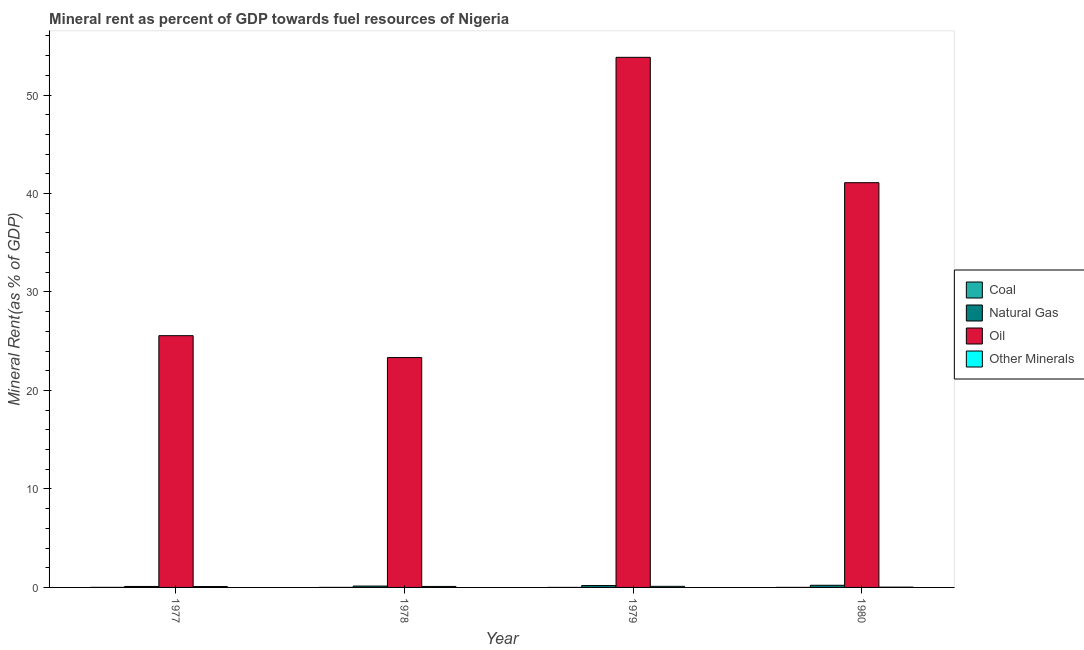How many different coloured bars are there?
Provide a short and direct response. 4. How many groups of bars are there?
Offer a very short reply. 4. Are the number of bars per tick equal to the number of legend labels?
Provide a succinct answer. Yes. How many bars are there on the 3rd tick from the right?
Your answer should be very brief. 4. What is the label of the 4th group of bars from the left?
Give a very brief answer. 1980. In how many cases, is the number of bars for a given year not equal to the number of legend labels?
Make the answer very short. 0. What is the  rent of other minerals in 1979?
Keep it short and to the point. 0.11. Across all years, what is the maximum natural gas rent?
Give a very brief answer. 0.22. Across all years, what is the minimum  rent of other minerals?
Give a very brief answer. 0.03. In which year was the oil rent maximum?
Your answer should be very brief. 1979. In which year was the  rent of other minerals minimum?
Provide a short and direct response. 1980. What is the total natural gas rent in the graph?
Your answer should be compact. 0.64. What is the difference between the coal rent in 1978 and that in 1979?
Your response must be concise. 0. What is the difference between the natural gas rent in 1979 and the oil rent in 1978?
Provide a short and direct response. 0.05. What is the average oil rent per year?
Provide a short and direct response. 35.96. In how many years, is the coal rent greater than 52 %?
Give a very brief answer. 0. What is the ratio of the  rent of other minerals in 1977 to that in 1978?
Give a very brief answer. 0.9. Is the difference between the oil rent in 1977 and 1979 greater than the difference between the  rent of other minerals in 1977 and 1979?
Offer a terse response. No. What is the difference between the highest and the second highest coal rent?
Provide a succinct answer. 0. What is the difference between the highest and the lowest natural gas rent?
Offer a terse response. 0.12. In how many years, is the natural gas rent greater than the average natural gas rent taken over all years?
Offer a terse response. 2. Is it the case that in every year, the sum of the oil rent and coal rent is greater than the sum of natural gas rent and  rent of other minerals?
Give a very brief answer. No. What does the 4th bar from the left in 1977 represents?
Ensure brevity in your answer.  Other Minerals. What does the 4th bar from the right in 1979 represents?
Keep it short and to the point. Coal. Is it the case that in every year, the sum of the coal rent and natural gas rent is greater than the oil rent?
Provide a short and direct response. No. How many bars are there?
Provide a short and direct response. 16. What is the difference between two consecutive major ticks on the Y-axis?
Provide a succinct answer. 10. How are the legend labels stacked?
Your answer should be very brief. Vertical. What is the title of the graph?
Offer a very short reply. Mineral rent as percent of GDP towards fuel resources of Nigeria. What is the label or title of the X-axis?
Make the answer very short. Year. What is the label or title of the Y-axis?
Your response must be concise. Mineral Rent(as % of GDP). What is the Mineral Rent(as % of GDP) in Coal in 1977?
Your response must be concise. 0. What is the Mineral Rent(as % of GDP) in Natural Gas in 1977?
Your answer should be very brief. 0.1. What is the Mineral Rent(as % of GDP) in Oil in 1977?
Your response must be concise. 25.56. What is the Mineral Rent(as % of GDP) of Other Minerals in 1977?
Provide a succinct answer. 0.09. What is the Mineral Rent(as % of GDP) in Coal in 1978?
Keep it short and to the point. 0. What is the Mineral Rent(as % of GDP) in Natural Gas in 1978?
Provide a succinct answer. 0.14. What is the Mineral Rent(as % of GDP) in Oil in 1978?
Provide a short and direct response. 23.34. What is the Mineral Rent(as % of GDP) of Other Minerals in 1978?
Your response must be concise. 0.1. What is the Mineral Rent(as % of GDP) in Coal in 1979?
Your answer should be very brief. 0. What is the Mineral Rent(as % of GDP) in Natural Gas in 1979?
Ensure brevity in your answer.  0.19. What is the Mineral Rent(as % of GDP) in Oil in 1979?
Offer a terse response. 53.83. What is the Mineral Rent(as % of GDP) of Other Minerals in 1979?
Your answer should be compact. 0.11. What is the Mineral Rent(as % of GDP) in Coal in 1980?
Offer a very short reply. 0. What is the Mineral Rent(as % of GDP) of Natural Gas in 1980?
Provide a succinct answer. 0.22. What is the Mineral Rent(as % of GDP) in Oil in 1980?
Ensure brevity in your answer.  41.1. What is the Mineral Rent(as % of GDP) of Other Minerals in 1980?
Make the answer very short. 0.03. Across all years, what is the maximum Mineral Rent(as % of GDP) of Coal?
Your answer should be very brief. 0. Across all years, what is the maximum Mineral Rent(as % of GDP) of Natural Gas?
Your answer should be compact. 0.22. Across all years, what is the maximum Mineral Rent(as % of GDP) in Oil?
Keep it short and to the point. 53.83. Across all years, what is the maximum Mineral Rent(as % of GDP) in Other Minerals?
Provide a succinct answer. 0.11. Across all years, what is the minimum Mineral Rent(as % of GDP) of Coal?
Your answer should be very brief. 0. Across all years, what is the minimum Mineral Rent(as % of GDP) in Natural Gas?
Provide a succinct answer. 0.1. Across all years, what is the minimum Mineral Rent(as % of GDP) in Oil?
Make the answer very short. 23.34. Across all years, what is the minimum Mineral Rent(as % of GDP) of Other Minerals?
Your answer should be compact. 0.03. What is the total Mineral Rent(as % of GDP) in Coal in the graph?
Provide a succinct answer. 0.01. What is the total Mineral Rent(as % of GDP) in Natural Gas in the graph?
Give a very brief answer. 0.64. What is the total Mineral Rent(as % of GDP) in Oil in the graph?
Keep it short and to the point. 143.83. What is the total Mineral Rent(as % of GDP) in Other Minerals in the graph?
Ensure brevity in your answer.  0.33. What is the difference between the Mineral Rent(as % of GDP) in Coal in 1977 and that in 1978?
Your answer should be compact. 0. What is the difference between the Mineral Rent(as % of GDP) in Natural Gas in 1977 and that in 1978?
Give a very brief answer. -0.04. What is the difference between the Mineral Rent(as % of GDP) in Oil in 1977 and that in 1978?
Your response must be concise. 2.22. What is the difference between the Mineral Rent(as % of GDP) of Other Minerals in 1977 and that in 1978?
Keep it short and to the point. -0.01. What is the difference between the Mineral Rent(as % of GDP) in Coal in 1977 and that in 1979?
Your answer should be compact. 0. What is the difference between the Mineral Rent(as % of GDP) of Natural Gas in 1977 and that in 1979?
Offer a terse response. -0.09. What is the difference between the Mineral Rent(as % of GDP) in Oil in 1977 and that in 1979?
Keep it short and to the point. -28.26. What is the difference between the Mineral Rent(as % of GDP) of Other Minerals in 1977 and that in 1979?
Ensure brevity in your answer.  -0.02. What is the difference between the Mineral Rent(as % of GDP) of Coal in 1977 and that in 1980?
Ensure brevity in your answer.  0. What is the difference between the Mineral Rent(as % of GDP) of Natural Gas in 1977 and that in 1980?
Your answer should be compact. -0.12. What is the difference between the Mineral Rent(as % of GDP) in Oil in 1977 and that in 1980?
Your response must be concise. -15.53. What is the difference between the Mineral Rent(as % of GDP) in Other Minerals in 1977 and that in 1980?
Ensure brevity in your answer.  0.06. What is the difference between the Mineral Rent(as % of GDP) in Coal in 1978 and that in 1979?
Offer a very short reply. 0. What is the difference between the Mineral Rent(as % of GDP) in Natural Gas in 1978 and that in 1979?
Make the answer very short. -0.05. What is the difference between the Mineral Rent(as % of GDP) in Oil in 1978 and that in 1979?
Offer a very short reply. -30.49. What is the difference between the Mineral Rent(as % of GDP) in Other Minerals in 1978 and that in 1979?
Offer a terse response. -0.01. What is the difference between the Mineral Rent(as % of GDP) of Coal in 1978 and that in 1980?
Offer a terse response. -0. What is the difference between the Mineral Rent(as % of GDP) in Natural Gas in 1978 and that in 1980?
Provide a short and direct response. -0.08. What is the difference between the Mineral Rent(as % of GDP) of Oil in 1978 and that in 1980?
Ensure brevity in your answer.  -17.76. What is the difference between the Mineral Rent(as % of GDP) in Other Minerals in 1978 and that in 1980?
Give a very brief answer. 0.07. What is the difference between the Mineral Rent(as % of GDP) in Coal in 1979 and that in 1980?
Keep it short and to the point. -0. What is the difference between the Mineral Rent(as % of GDP) of Natural Gas in 1979 and that in 1980?
Offer a very short reply. -0.03. What is the difference between the Mineral Rent(as % of GDP) in Oil in 1979 and that in 1980?
Give a very brief answer. 12.73. What is the difference between the Mineral Rent(as % of GDP) in Other Minerals in 1979 and that in 1980?
Give a very brief answer. 0.08. What is the difference between the Mineral Rent(as % of GDP) of Coal in 1977 and the Mineral Rent(as % of GDP) of Natural Gas in 1978?
Offer a very short reply. -0.14. What is the difference between the Mineral Rent(as % of GDP) in Coal in 1977 and the Mineral Rent(as % of GDP) in Oil in 1978?
Give a very brief answer. -23.34. What is the difference between the Mineral Rent(as % of GDP) of Coal in 1977 and the Mineral Rent(as % of GDP) of Other Minerals in 1978?
Keep it short and to the point. -0.1. What is the difference between the Mineral Rent(as % of GDP) of Natural Gas in 1977 and the Mineral Rent(as % of GDP) of Oil in 1978?
Offer a very short reply. -23.24. What is the difference between the Mineral Rent(as % of GDP) of Natural Gas in 1977 and the Mineral Rent(as % of GDP) of Other Minerals in 1978?
Provide a short and direct response. -0. What is the difference between the Mineral Rent(as % of GDP) of Oil in 1977 and the Mineral Rent(as % of GDP) of Other Minerals in 1978?
Ensure brevity in your answer.  25.46. What is the difference between the Mineral Rent(as % of GDP) of Coal in 1977 and the Mineral Rent(as % of GDP) of Natural Gas in 1979?
Provide a short and direct response. -0.19. What is the difference between the Mineral Rent(as % of GDP) of Coal in 1977 and the Mineral Rent(as % of GDP) of Oil in 1979?
Ensure brevity in your answer.  -53.82. What is the difference between the Mineral Rent(as % of GDP) in Coal in 1977 and the Mineral Rent(as % of GDP) in Other Minerals in 1979?
Ensure brevity in your answer.  -0.11. What is the difference between the Mineral Rent(as % of GDP) in Natural Gas in 1977 and the Mineral Rent(as % of GDP) in Oil in 1979?
Offer a terse response. -53.73. What is the difference between the Mineral Rent(as % of GDP) of Natural Gas in 1977 and the Mineral Rent(as % of GDP) of Other Minerals in 1979?
Your response must be concise. -0.01. What is the difference between the Mineral Rent(as % of GDP) in Oil in 1977 and the Mineral Rent(as % of GDP) in Other Minerals in 1979?
Make the answer very short. 25.45. What is the difference between the Mineral Rent(as % of GDP) of Coal in 1977 and the Mineral Rent(as % of GDP) of Natural Gas in 1980?
Ensure brevity in your answer.  -0.21. What is the difference between the Mineral Rent(as % of GDP) of Coal in 1977 and the Mineral Rent(as % of GDP) of Oil in 1980?
Give a very brief answer. -41.09. What is the difference between the Mineral Rent(as % of GDP) of Coal in 1977 and the Mineral Rent(as % of GDP) of Other Minerals in 1980?
Your answer should be compact. -0.02. What is the difference between the Mineral Rent(as % of GDP) in Natural Gas in 1977 and the Mineral Rent(as % of GDP) in Oil in 1980?
Provide a short and direct response. -41. What is the difference between the Mineral Rent(as % of GDP) in Natural Gas in 1977 and the Mineral Rent(as % of GDP) in Other Minerals in 1980?
Ensure brevity in your answer.  0.07. What is the difference between the Mineral Rent(as % of GDP) of Oil in 1977 and the Mineral Rent(as % of GDP) of Other Minerals in 1980?
Ensure brevity in your answer.  25.54. What is the difference between the Mineral Rent(as % of GDP) in Coal in 1978 and the Mineral Rent(as % of GDP) in Natural Gas in 1979?
Your answer should be compact. -0.19. What is the difference between the Mineral Rent(as % of GDP) in Coal in 1978 and the Mineral Rent(as % of GDP) in Oil in 1979?
Your response must be concise. -53.82. What is the difference between the Mineral Rent(as % of GDP) of Coal in 1978 and the Mineral Rent(as % of GDP) of Other Minerals in 1979?
Offer a very short reply. -0.11. What is the difference between the Mineral Rent(as % of GDP) of Natural Gas in 1978 and the Mineral Rent(as % of GDP) of Oil in 1979?
Give a very brief answer. -53.69. What is the difference between the Mineral Rent(as % of GDP) in Natural Gas in 1978 and the Mineral Rent(as % of GDP) in Other Minerals in 1979?
Make the answer very short. 0.03. What is the difference between the Mineral Rent(as % of GDP) in Oil in 1978 and the Mineral Rent(as % of GDP) in Other Minerals in 1979?
Ensure brevity in your answer.  23.23. What is the difference between the Mineral Rent(as % of GDP) of Coal in 1978 and the Mineral Rent(as % of GDP) of Natural Gas in 1980?
Make the answer very short. -0.22. What is the difference between the Mineral Rent(as % of GDP) in Coal in 1978 and the Mineral Rent(as % of GDP) in Oil in 1980?
Give a very brief answer. -41.09. What is the difference between the Mineral Rent(as % of GDP) in Coal in 1978 and the Mineral Rent(as % of GDP) in Other Minerals in 1980?
Offer a terse response. -0.03. What is the difference between the Mineral Rent(as % of GDP) of Natural Gas in 1978 and the Mineral Rent(as % of GDP) of Oil in 1980?
Keep it short and to the point. -40.96. What is the difference between the Mineral Rent(as % of GDP) of Natural Gas in 1978 and the Mineral Rent(as % of GDP) of Other Minerals in 1980?
Offer a very short reply. 0.11. What is the difference between the Mineral Rent(as % of GDP) of Oil in 1978 and the Mineral Rent(as % of GDP) of Other Minerals in 1980?
Provide a short and direct response. 23.31. What is the difference between the Mineral Rent(as % of GDP) in Coal in 1979 and the Mineral Rent(as % of GDP) in Natural Gas in 1980?
Make the answer very short. -0.22. What is the difference between the Mineral Rent(as % of GDP) of Coal in 1979 and the Mineral Rent(as % of GDP) of Oil in 1980?
Your answer should be compact. -41.1. What is the difference between the Mineral Rent(as % of GDP) in Coal in 1979 and the Mineral Rent(as % of GDP) in Other Minerals in 1980?
Give a very brief answer. -0.03. What is the difference between the Mineral Rent(as % of GDP) of Natural Gas in 1979 and the Mineral Rent(as % of GDP) of Oil in 1980?
Offer a terse response. -40.91. What is the difference between the Mineral Rent(as % of GDP) of Natural Gas in 1979 and the Mineral Rent(as % of GDP) of Other Minerals in 1980?
Your response must be concise. 0.16. What is the difference between the Mineral Rent(as % of GDP) in Oil in 1979 and the Mineral Rent(as % of GDP) in Other Minerals in 1980?
Provide a succinct answer. 53.8. What is the average Mineral Rent(as % of GDP) in Coal per year?
Offer a very short reply. 0. What is the average Mineral Rent(as % of GDP) in Natural Gas per year?
Offer a very short reply. 0.16. What is the average Mineral Rent(as % of GDP) in Oil per year?
Your answer should be compact. 35.96. What is the average Mineral Rent(as % of GDP) in Other Minerals per year?
Offer a terse response. 0.08. In the year 1977, what is the difference between the Mineral Rent(as % of GDP) in Coal and Mineral Rent(as % of GDP) in Natural Gas?
Make the answer very short. -0.09. In the year 1977, what is the difference between the Mineral Rent(as % of GDP) in Coal and Mineral Rent(as % of GDP) in Oil?
Your response must be concise. -25.56. In the year 1977, what is the difference between the Mineral Rent(as % of GDP) of Coal and Mineral Rent(as % of GDP) of Other Minerals?
Offer a very short reply. -0.09. In the year 1977, what is the difference between the Mineral Rent(as % of GDP) of Natural Gas and Mineral Rent(as % of GDP) of Oil?
Your answer should be compact. -25.47. In the year 1977, what is the difference between the Mineral Rent(as % of GDP) of Natural Gas and Mineral Rent(as % of GDP) of Other Minerals?
Offer a very short reply. 0.01. In the year 1977, what is the difference between the Mineral Rent(as % of GDP) of Oil and Mineral Rent(as % of GDP) of Other Minerals?
Your answer should be compact. 25.47. In the year 1978, what is the difference between the Mineral Rent(as % of GDP) in Coal and Mineral Rent(as % of GDP) in Natural Gas?
Provide a short and direct response. -0.14. In the year 1978, what is the difference between the Mineral Rent(as % of GDP) in Coal and Mineral Rent(as % of GDP) in Oil?
Give a very brief answer. -23.34. In the year 1978, what is the difference between the Mineral Rent(as % of GDP) of Coal and Mineral Rent(as % of GDP) of Other Minerals?
Make the answer very short. -0.1. In the year 1978, what is the difference between the Mineral Rent(as % of GDP) in Natural Gas and Mineral Rent(as % of GDP) in Oil?
Offer a very short reply. -23.2. In the year 1978, what is the difference between the Mineral Rent(as % of GDP) in Natural Gas and Mineral Rent(as % of GDP) in Other Minerals?
Your answer should be compact. 0.04. In the year 1978, what is the difference between the Mineral Rent(as % of GDP) of Oil and Mineral Rent(as % of GDP) of Other Minerals?
Your response must be concise. 23.24. In the year 1979, what is the difference between the Mineral Rent(as % of GDP) in Coal and Mineral Rent(as % of GDP) in Natural Gas?
Provide a succinct answer. -0.19. In the year 1979, what is the difference between the Mineral Rent(as % of GDP) of Coal and Mineral Rent(as % of GDP) of Oil?
Your answer should be very brief. -53.83. In the year 1979, what is the difference between the Mineral Rent(as % of GDP) of Coal and Mineral Rent(as % of GDP) of Other Minerals?
Your answer should be compact. -0.11. In the year 1979, what is the difference between the Mineral Rent(as % of GDP) in Natural Gas and Mineral Rent(as % of GDP) in Oil?
Provide a short and direct response. -53.64. In the year 1979, what is the difference between the Mineral Rent(as % of GDP) in Natural Gas and Mineral Rent(as % of GDP) in Other Minerals?
Provide a succinct answer. 0.08. In the year 1979, what is the difference between the Mineral Rent(as % of GDP) in Oil and Mineral Rent(as % of GDP) in Other Minerals?
Keep it short and to the point. 53.72. In the year 1980, what is the difference between the Mineral Rent(as % of GDP) of Coal and Mineral Rent(as % of GDP) of Natural Gas?
Offer a terse response. -0.22. In the year 1980, what is the difference between the Mineral Rent(as % of GDP) in Coal and Mineral Rent(as % of GDP) in Oil?
Offer a terse response. -41.09. In the year 1980, what is the difference between the Mineral Rent(as % of GDP) in Coal and Mineral Rent(as % of GDP) in Other Minerals?
Make the answer very short. -0.03. In the year 1980, what is the difference between the Mineral Rent(as % of GDP) in Natural Gas and Mineral Rent(as % of GDP) in Oil?
Ensure brevity in your answer.  -40.88. In the year 1980, what is the difference between the Mineral Rent(as % of GDP) of Natural Gas and Mineral Rent(as % of GDP) of Other Minerals?
Offer a terse response. 0.19. In the year 1980, what is the difference between the Mineral Rent(as % of GDP) in Oil and Mineral Rent(as % of GDP) in Other Minerals?
Offer a very short reply. 41.07. What is the ratio of the Mineral Rent(as % of GDP) of Coal in 1977 to that in 1978?
Your response must be concise. 1.53. What is the ratio of the Mineral Rent(as % of GDP) in Natural Gas in 1977 to that in 1978?
Your answer should be compact. 0.7. What is the ratio of the Mineral Rent(as % of GDP) of Oil in 1977 to that in 1978?
Keep it short and to the point. 1.1. What is the ratio of the Mineral Rent(as % of GDP) in Other Minerals in 1977 to that in 1978?
Offer a terse response. 0.9. What is the ratio of the Mineral Rent(as % of GDP) of Coal in 1977 to that in 1979?
Your answer should be very brief. 3.22. What is the ratio of the Mineral Rent(as % of GDP) of Natural Gas in 1977 to that in 1979?
Keep it short and to the point. 0.51. What is the ratio of the Mineral Rent(as % of GDP) in Oil in 1977 to that in 1979?
Your answer should be compact. 0.47. What is the ratio of the Mineral Rent(as % of GDP) in Other Minerals in 1977 to that in 1979?
Your answer should be very brief. 0.81. What is the ratio of the Mineral Rent(as % of GDP) of Coal in 1977 to that in 1980?
Give a very brief answer. 1.52. What is the ratio of the Mineral Rent(as % of GDP) of Natural Gas in 1977 to that in 1980?
Your answer should be compact. 0.45. What is the ratio of the Mineral Rent(as % of GDP) of Oil in 1977 to that in 1980?
Offer a terse response. 0.62. What is the ratio of the Mineral Rent(as % of GDP) of Other Minerals in 1977 to that in 1980?
Ensure brevity in your answer.  3.27. What is the ratio of the Mineral Rent(as % of GDP) of Coal in 1978 to that in 1979?
Give a very brief answer. 2.1. What is the ratio of the Mineral Rent(as % of GDP) of Natural Gas in 1978 to that in 1979?
Ensure brevity in your answer.  0.74. What is the ratio of the Mineral Rent(as % of GDP) of Oil in 1978 to that in 1979?
Keep it short and to the point. 0.43. What is the ratio of the Mineral Rent(as % of GDP) in Other Minerals in 1978 to that in 1979?
Give a very brief answer. 0.9. What is the ratio of the Mineral Rent(as % of GDP) of Coal in 1978 to that in 1980?
Make the answer very short. 0.99. What is the ratio of the Mineral Rent(as % of GDP) of Natural Gas in 1978 to that in 1980?
Your response must be concise. 0.64. What is the ratio of the Mineral Rent(as % of GDP) of Oil in 1978 to that in 1980?
Give a very brief answer. 0.57. What is the ratio of the Mineral Rent(as % of GDP) in Other Minerals in 1978 to that in 1980?
Provide a short and direct response. 3.63. What is the ratio of the Mineral Rent(as % of GDP) in Coal in 1979 to that in 1980?
Your response must be concise. 0.47. What is the ratio of the Mineral Rent(as % of GDP) in Natural Gas in 1979 to that in 1980?
Your answer should be compact. 0.87. What is the ratio of the Mineral Rent(as % of GDP) of Oil in 1979 to that in 1980?
Provide a short and direct response. 1.31. What is the ratio of the Mineral Rent(as % of GDP) in Other Minerals in 1979 to that in 1980?
Ensure brevity in your answer.  4.03. What is the difference between the highest and the second highest Mineral Rent(as % of GDP) of Coal?
Your answer should be compact. 0. What is the difference between the highest and the second highest Mineral Rent(as % of GDP) in Natural Gas?
Provide a succinct answer. 0.03. What is the difference between the highest and the second highest Mineral Rent(as % of GDP) of Oil?
Make the answer very short. 12.73. What is the difference between the highest and the second highest Mineral Rent(as % of GDP) in Other Minerals?
Provide a succinct answer. 0.01. What is the difference between the highest and the lowest Mineral Rent(as % of GDP) of Coal?
Provide a succinct answer. 0. What is the difference between the highest and the lowest Mineral Rent(as % of GDP) of Natural Gas?
Make the answer very short. 0.12. What is the difference between the highest and the lowest Mineral Rent(as % of GDP) in Oil?
Offer a very short reply. 30.49. What is the difference between the highest and the lowest Mineral Rent(as % of GDP) of Other Minerals?
Your answer should be compact. 0.08. 